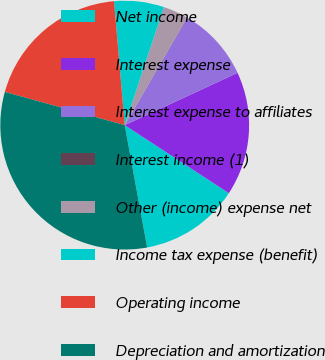Convert chart to OTSL. <chart><loc_0><loc_0><loc_500><loc_500><pie_chart><fcel>Net income<fcel>Interest expense<fcel>Interest expense to affiliates<fcel>Interest income (1)<fcel>Other (income) expense net<fcel>Income tax expense (benefit)<fcel>Operating income<fcel>Depreciation and amortization<nl><fcel>12.9%<fcel>16.12%<fcel>9.69%<fcel>0.04%<fcel>3.26%<fcel>6.47%<fcel>19.33%<fcel>32.19%<nl></chart> 